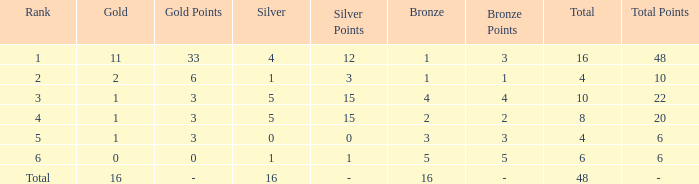How many total gold are less than 4? 0.0. 